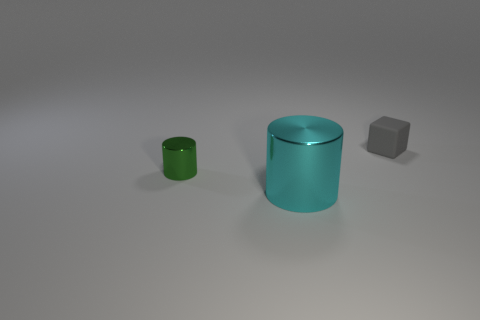Are there any other things that are the same size as the cyan shiny thing?
Make the answer very short. No. Are there any other things that have the same shape as the gray thing?
Provide a short and direct response. No. There is a metal object left of the large metal thing; does it have the same shape as the shiny object on the right side of the small green thing?
Provide a succinct answer. Yes. There is a small green thing that is the same shape as the large cyan metallic object; what material is it?
Offer a terse response. Metal. What number of balls are either tiny shiny things or big cyan things?
Ensure brevity in your answer.  0. How many green cylinders are made of the same material as the gray object?
Your response must be concise. 0. Is the tiny thing that is in front of the tiny rubber object made of the same material as the thing that is in front of the tiny green thing?
Your response must be concise. Yes. What number of cylinders are to the left of the metal object that is in front of the small thing in front of the tiny rubber thing?
Make the answer very short. 1. There is a tiny object that is left of the matte block; is it the same color as the metallic thing that is in front of the tiny metal thing?
Your response must be concise. No. The small object on the left side of the tiny thing that is behind the small green shiny object is what color?
Offer a terse response. Green. 